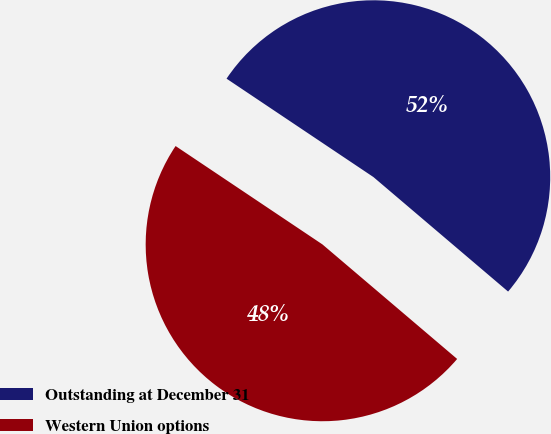<chart> <loc_0><loc_0><loc_500><loc_500><pie_chart><fcel>Outstanding at December 31<fcel>Western Union options<nl><fcel>51.82%<fcel>48.18%<nl></chart> 